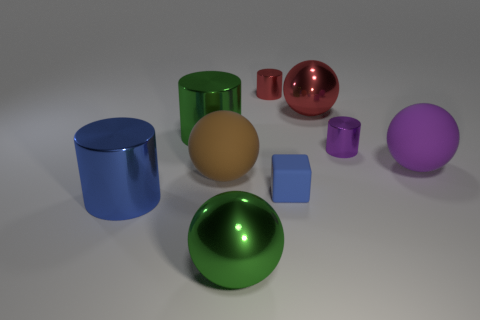There is a blue thing that is the same material as the red cylinder; what is its size?
Provide a succinct answer. Large. Are there any other things that have the same color as the tiny block?
Offer a very short reply. Yes. What is the color of the big metal sphere that is behind the blue matte thing?
Your response must be concise. Red. There is a matte thing to the left of the large object that is in front of the blue shiny object; is there a big cylinder that is in front of it?
Make the answer very short. Yes. Are there more big spheres on the right side of the big green metal ball than tiny matte things?
Provide a succinct answer. Yes. Do the green object that is in front of the blue metallic thing and the big purple thing have the same shape?
Your answer should be very brief. Yes. How many things are either tiny rubber things or large things that are in front of the large red thing?
Keep it short and to the point. 6. There is a metallic object that is both to the left of the green sphere and right of the blue metal cylinder; how big is it?
Ensure brevity in your answer.  Large. Are there more big green objects that are right of the big green shiny cylinder than big green metal objects behind the small red metal cylinder?
Make the answer very short. Yes. There is a purple rubber object; does it have the same shape as the green object that is in front of the brown rubber sphere?
Offer a terse response. Yes. 